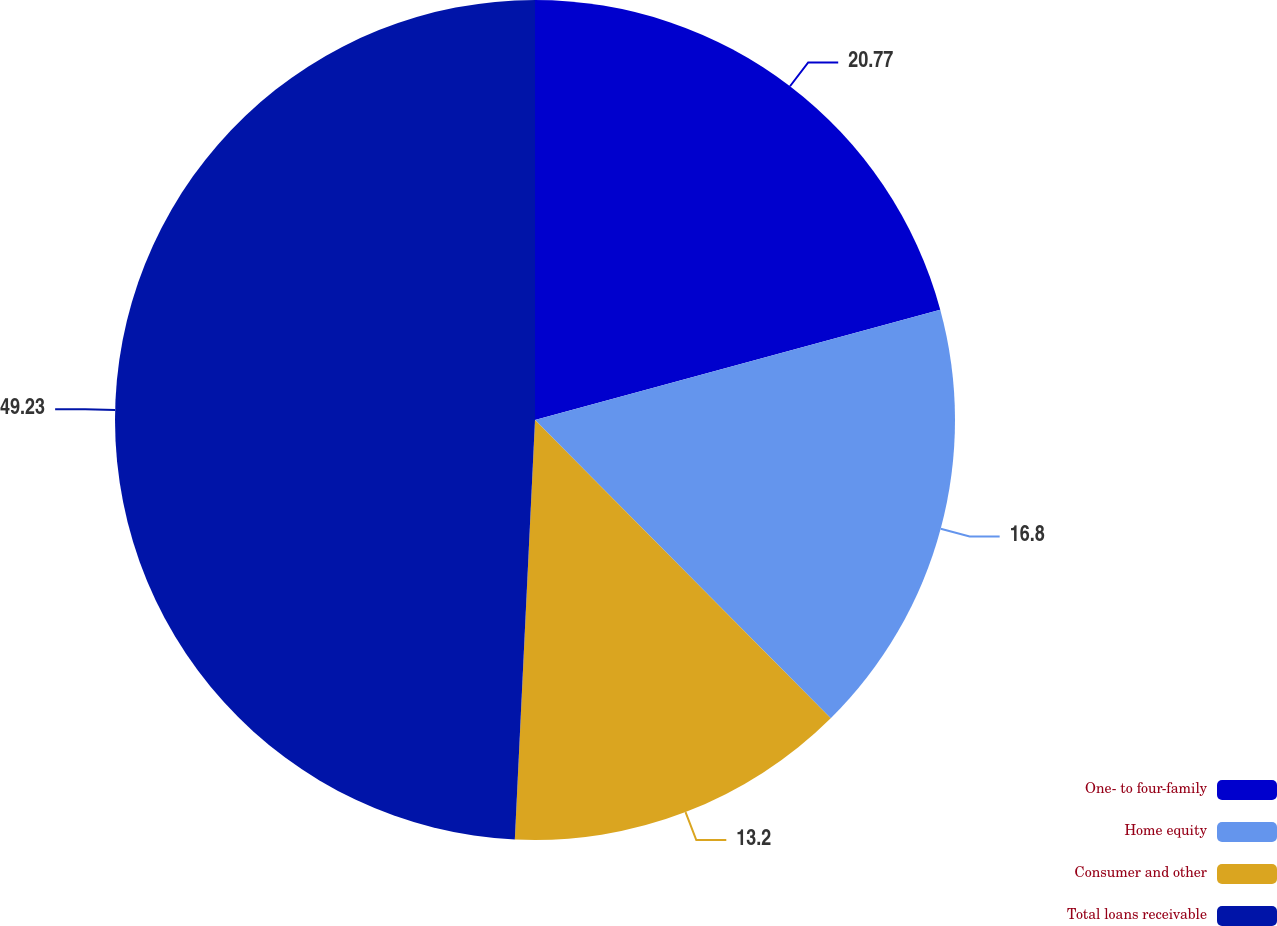<chart> <loc_0><loc_0><loc_500><loc_500><pie_chart><fcel>One- to four-family<fcel>Home equity<fcel>Consumer and other<fcel>Total loans receivable<nl><fcel>20.77%<fcel>16.8%<fcel>13.2%<fcel>49.24%<nl></chart> 